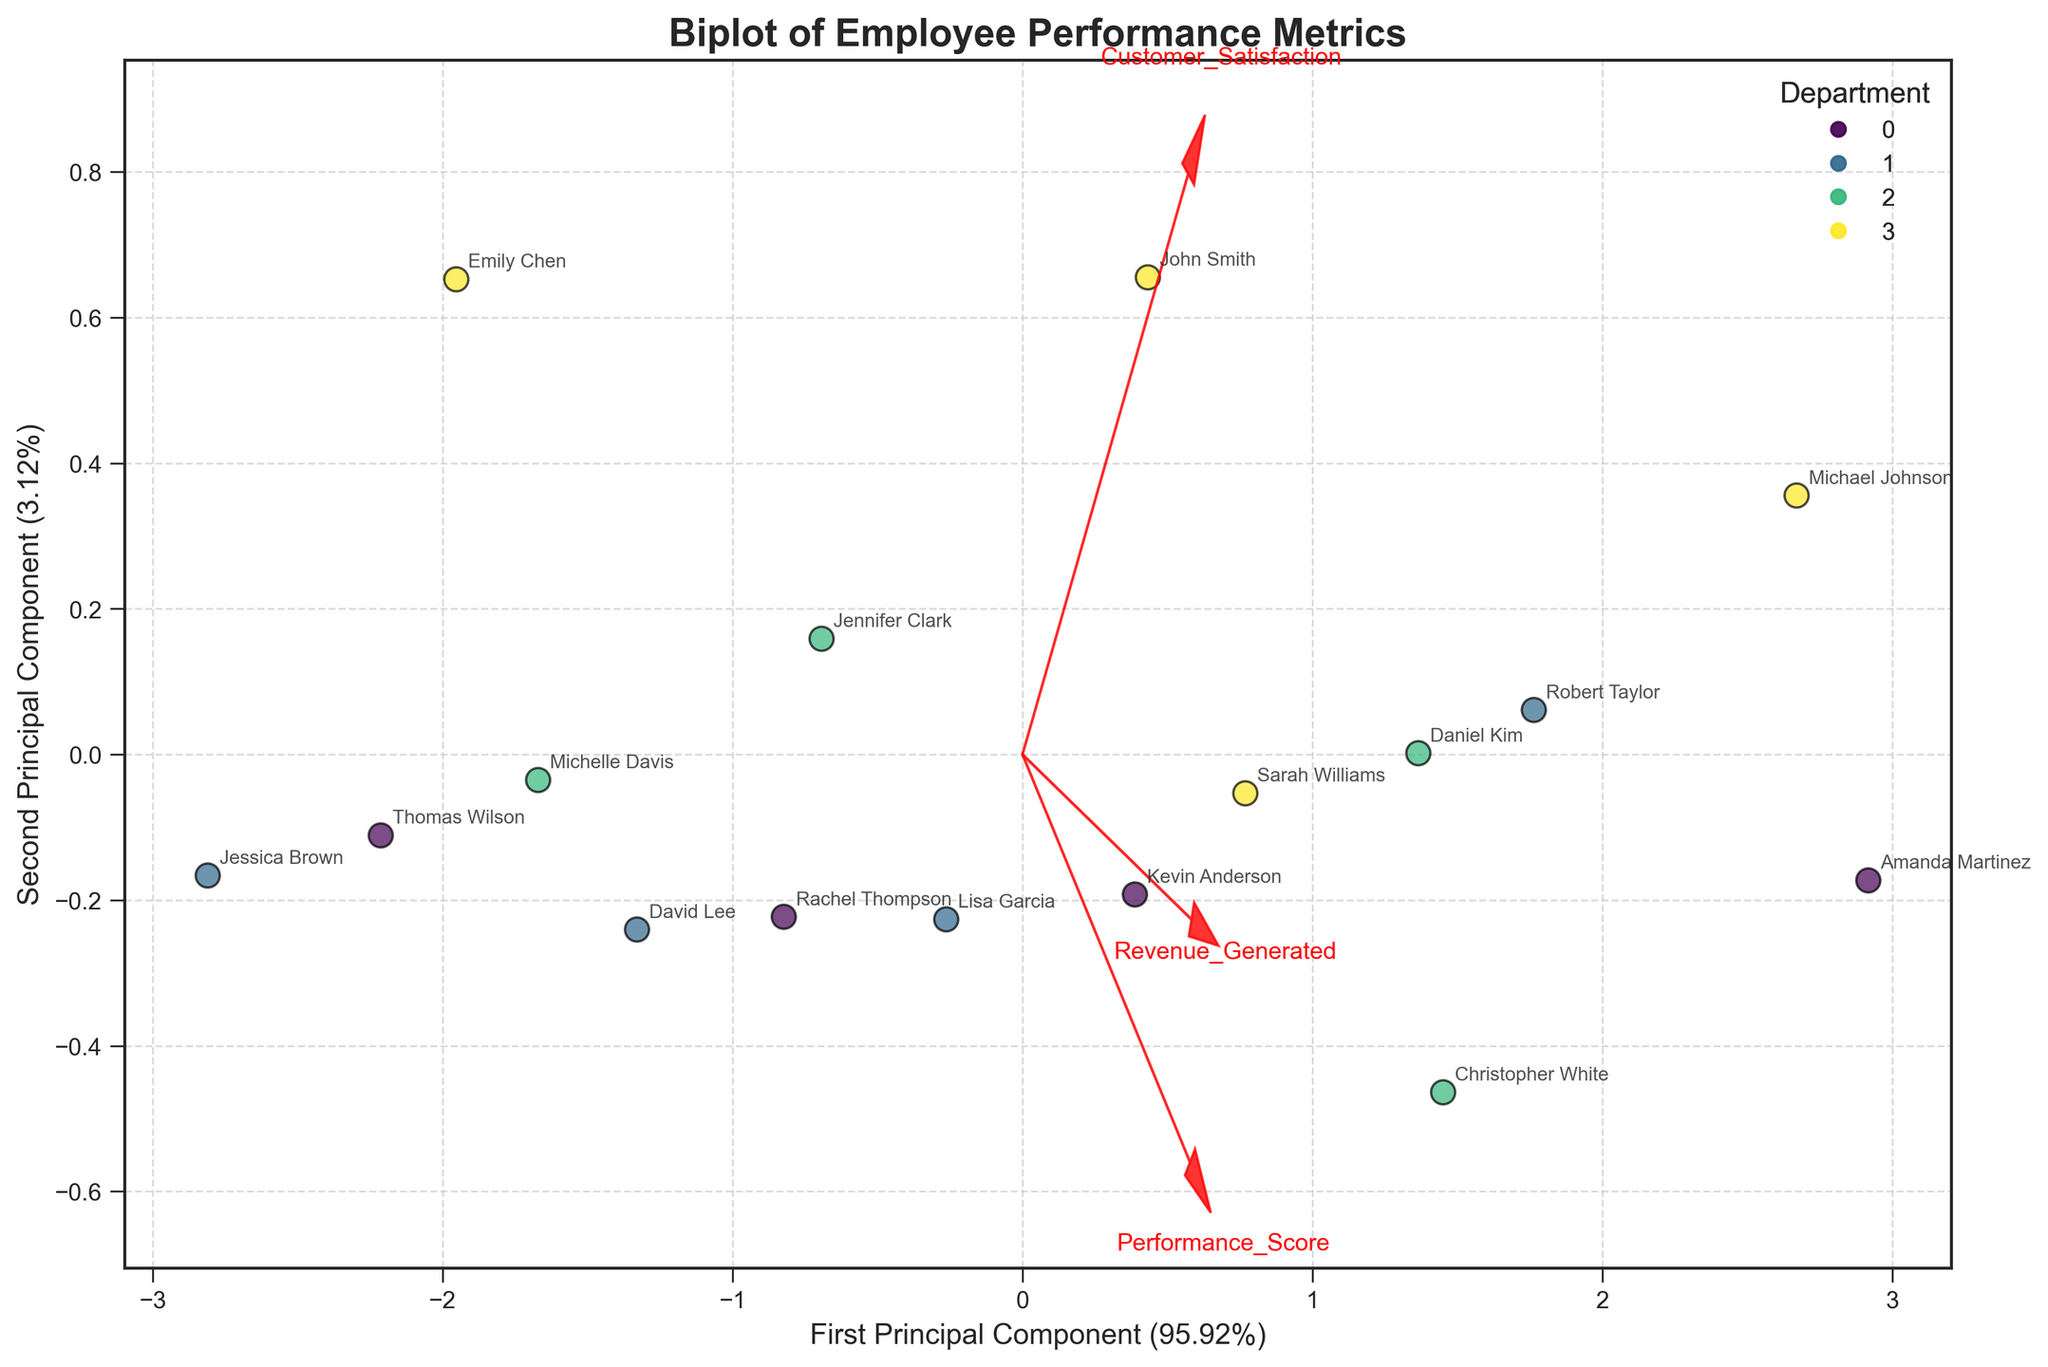What's the title of the plot? The title is usually located at the top of the plot. In this case, the title is clearly labeled as 'Biplot of Employee Performance Metrics.'
Answer: Biplot of Employee Performance Metrics How many departments are represented in the plot? There is a legend on the upper right of the plot that lists the departments. By counting the entries, we see there are four departments: Sales, Marketing, Engineering, and Product.
Answer: Four Which feature vector has the highest absolute value in the second principal component? The feature vectors are shown as red arrows, with their labels. By examining the length of the arrows along the y-axis (second principal component), the Revenue_Generated vector has the highest absolute value.
Answer: Revenue_Generated Which employee has the highest first principal component value? By locating the data points on the x-axis (first principal component), Amanda Martinez appears furthest to the right, indicating the highest first principal component value.
Answer: Amanda Martinez What is the approximate explained variance ratio for the first principal component? The x-axis label shows the percentage of explained variance for the first principal component. It states that it is approximately 62%.
Answer: 62% Which department has the most tightly clustered data points? By observing the scatter plot, the points representing the Sales department are the closest together, indicating the least variance within that group.
Answer: Sales Is there a significant overlap between the Engineering and Product departments? By examining the positioning of the data points, there is a notable overlap between the data points of Engineering and Product departments, indicating that their performance metrics are quite similar.
Answer: Yes What does the direction of the Customer_Satisfaction vector indicate about its correlation with the principal components? The Customer_Satisfaction vector is plotted positively along both principal components, suggesting a positive correlation with both the first and second principal components.
Answer: Positive correlation with both Which employee has the closest performance metrics to Jennifer Clark? To find the closest data point to Jennifer Clark's, locate her position and identify the nearest point. Rachel Thompson's data point is closest to Jennifer Clark's.
Answer: Rachel Thompson What do the lengths of the feature vectors represent? The lengths and directions of the red arrows (feature vectors) represent the degree to which each feature (Performance_Score, Customer_Satisfaction, Revenue_Generated) contributes to the two principal components. Longer arrows indicate a stronger contribution.
Answer: Contribution strength to principal components 